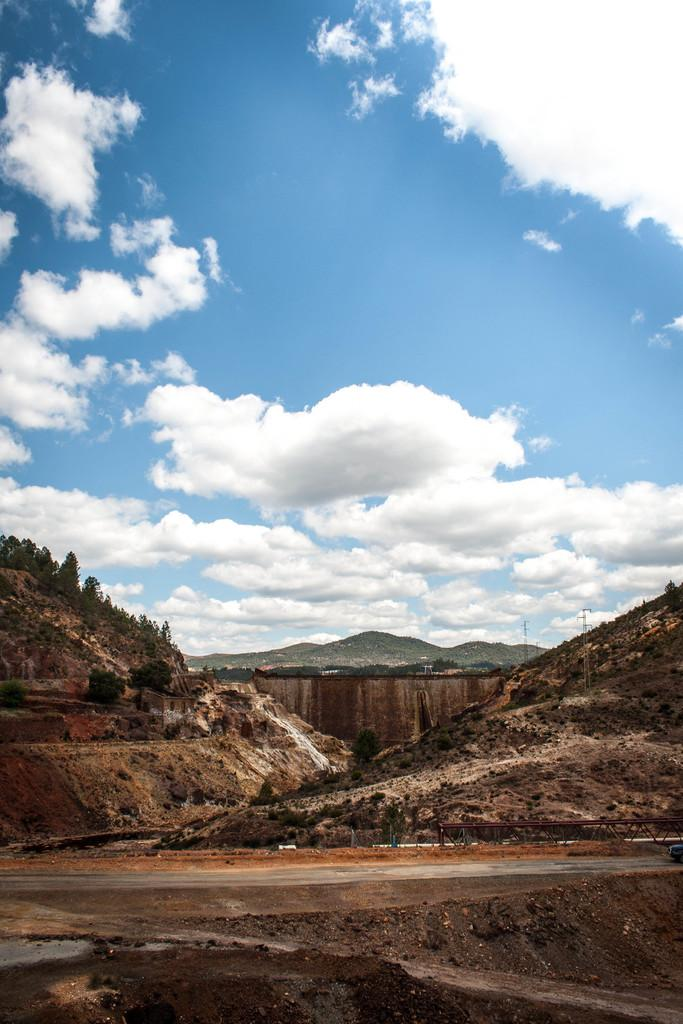What type of natural formation can be seen in the image? There is a group of mountains in the image. What structures are present in the image? There are poles in the image. What type of vegetation is visible in the image? There are trees in the image. What is the condition of the sky in the image? The sky is cloudy in the image. Where is the pickle located in the image? There is no pickle present in the image. What shape is the bucket in the image? There is no bucket present in the image. 